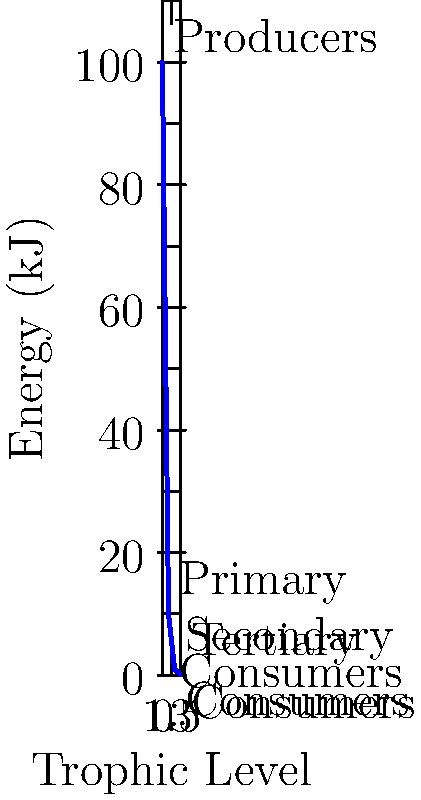As a data scientist analyzing animal disturbance data, you're studying energy transfer in an ecosystem. The energy pyramid shown represents the flow of energy through trophic levels, starting with 100 kJ at the producer level. If the energy transfer efficiency between each trophic level is constant, what percentage of energy is transferred from one trophic level to the next? To solve this problem, we'll follow these steps:

1. Identify the energy values at each trophic level:
   - Producers: 100 kJ
   - Primary Consumers: 10 kJ
   - Secondary Consumers: 1 kJ
   - Tertiary Consumers: 0.1 kJ

2. Calculate the energy transfer ratio between consecutive levels:
   - Primary to Producers: $\frac{10}{100} = 0.1$
   - Secondary to Primary: $\frac{1}{10} = 0.1$
   - Tertiary to Secondary: $\frac{0.1}{1} = 0.1$

3. Observe that the ratio is constant (0.1) between all levels.

4. Convert the ratio to a percentage:
   $0.1 \times 100\% = 10\%$

Therefore, the energy transfer efficiency between each trophic level is 10%.

This constant percentage aligns with the ecological "10% rule," which states that approximately 10% of the energy available at one trophic level is transferred to the next level.
Answer: 10% 